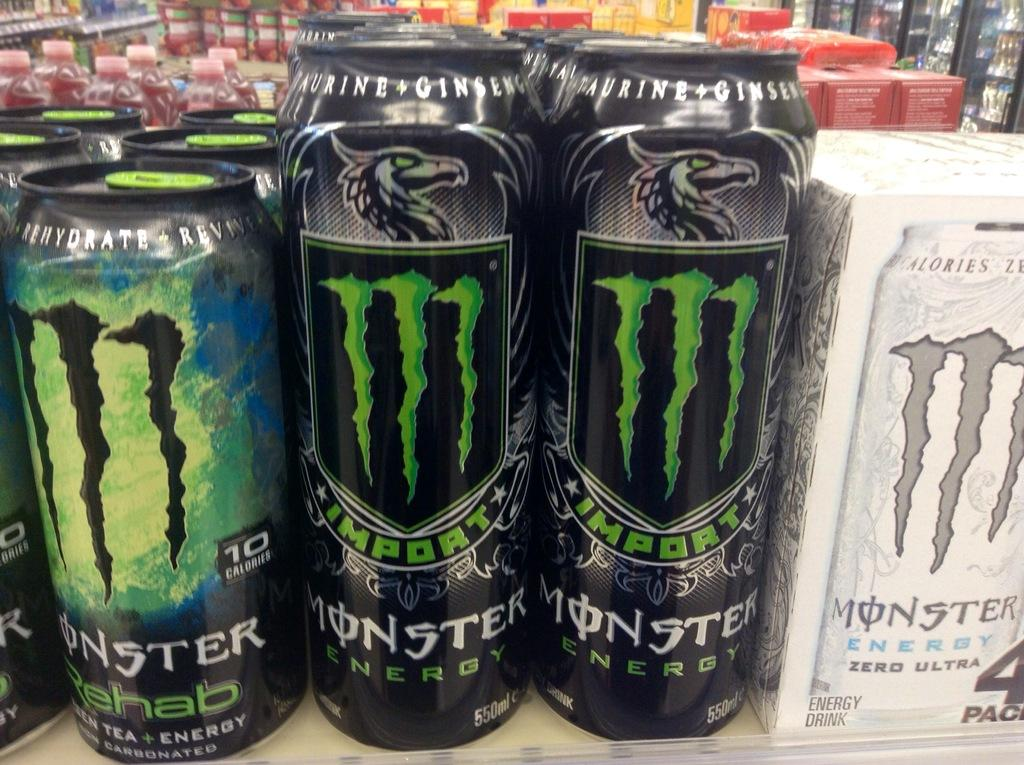<image>
Write a terse but informative summary of the picture. Cans of Monster Energy on a shelf in a grocery store. 